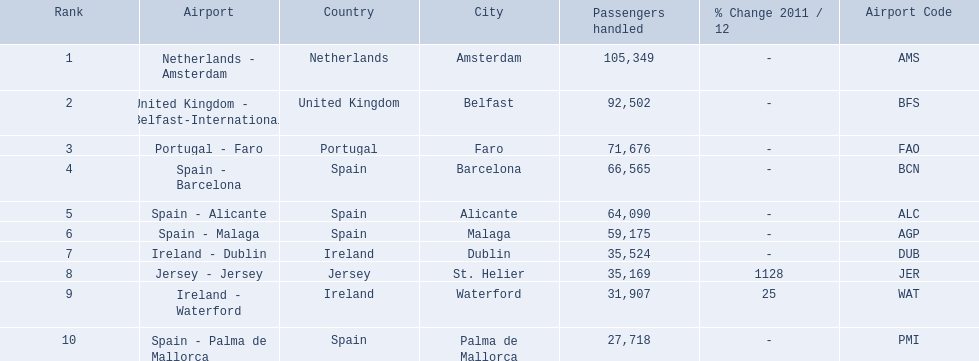What are all of the routes out of the london southend airport? Netherlands - Amsterdam, United Kingdom - Belfast-International, Portugal - Faro, Spain - Barcelona, Spain - Alicante, Spain - Malaga, Ireland - Dublin, Jersey - Jersey, Ireland - Waterford, Spain - Palma de Mallorca. How many passengers have traveled to each destination? 105,349, 92,502, 71,676, 66,565, 64,090, 59,175, 35,524, 35,169, 31,907, 27,718. And which destination has been the most popular to passengers? Netherlands - Amsterdam. 